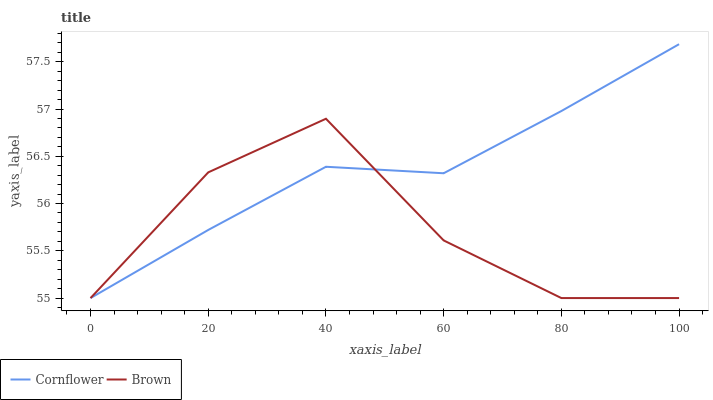Does Brown have the minimum area under the curve?
Answer yes or no. Yes. Does Cornflower have the maximum area under the curve?
Answer yes or no. Yes. Does Brown have the maximum area under the curve?
Answer yes or no. No. Is Cornflower the smoothest?
Answer yes or no. Yes. Is Brown the roughest?
Answer yes or no. Yes. Is Brown the smoothest?
Answer yes or no. No. Does Cornflower have the lowest value?
Answer yes or no. Yes. Does Cornflower have the highest value?
Answer yes or no. Yes. Does Brown have the highest value?
Answer yes or no. No. Does Cornflower intersect Brown?
Answer yes or no. Yes. Is Cornflower less than Brown?
Answer yes or no. No. Is Cornflower greater than Brown?
Answer yes or no. No. 